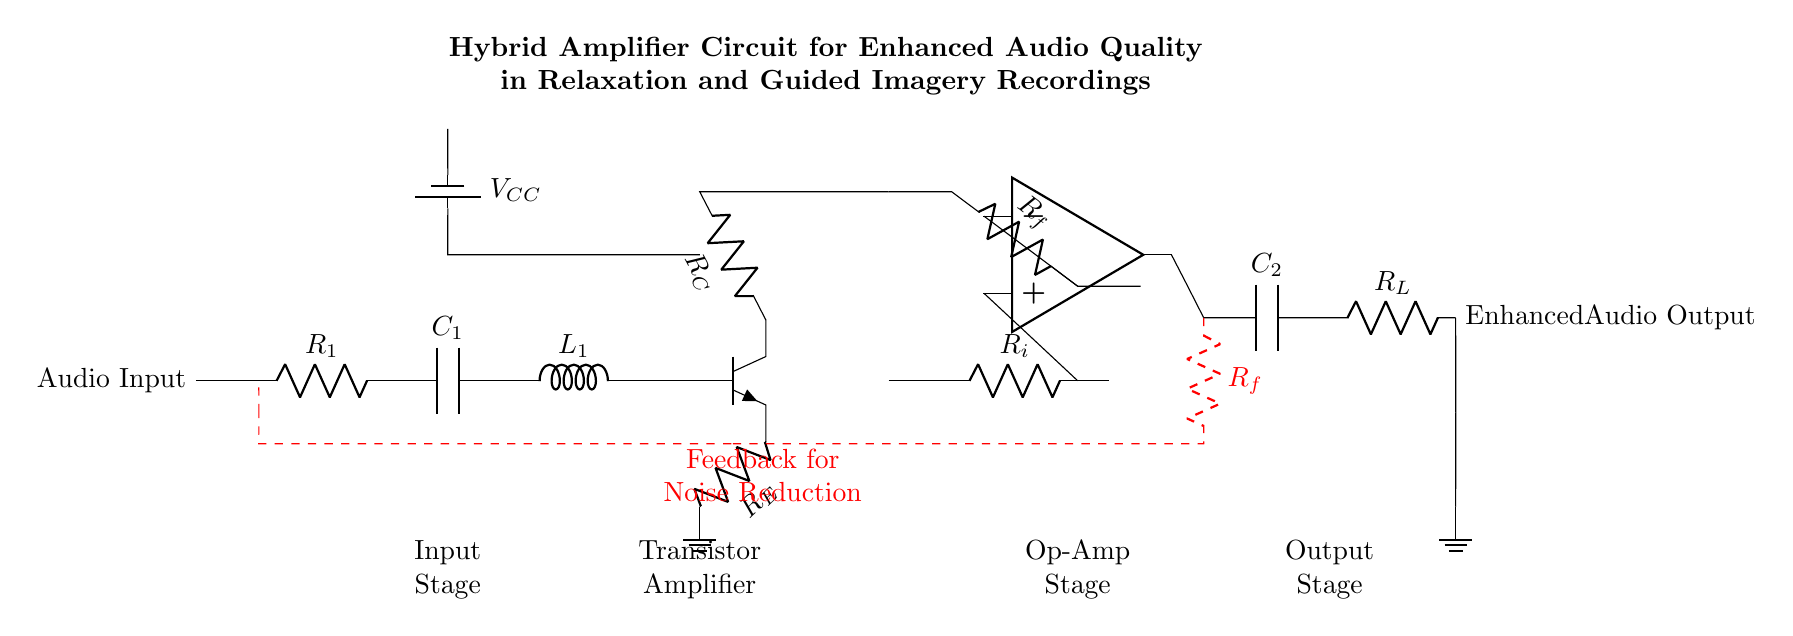What is the power supply voltage in this circuit? The voltage from the power supply is labeled as \( V_{CC} \) in the circuit diagram. It is represented next to the battery symbol, indicating that it provides the necessary voltage for the circuit operation.
Answer: VCC What type of transistor is used in this amplifier? The diagram indicates an NP transistor with the label npn next to the transistor symbol, identifying its type as an NPN transistor, commonly used in amplifier circuits for signal amplification.
Answer: NPN What component is used for filtering in the output stage? The component labeled as \( C_2 \) in the output stage serves as a capacitor, which is typically used for filtering high-frequency noise and smoothing out the output signal to enhance audio quality.
Answer: Capacitor What role does the resistor \( R_f \) serve in this circuit? The feedback resistor labeled \( R_f \) is used in the feedback loop indicated by the red dashed line, which helps stabilize the gain of the operational amplifier and reduces noise further enhancing audio quality.
Answer: Feedback resistor What type of configuration is the operational amplifier set in? The operational amplifier is set in a non-inverting configuration based on its positive input connection from \( R_i \) and negative input connection from \( R_f \), which allows for improved signal gain and fidelity in the output.
Answer: Non-inverting What is the purpose of the inductor \( L_1 \) in this circuit? The inductor \( L_1 \) is used to block high-frequency noise and allows low-frequency audio signals to pass through, which is crucial in enhancing the audio quality, especially for relaxation recordings.
Answer: Noise filtering What does the label at the bottom left of the circuit represent? The label "Input Stage" at the bottom left indicates that the components connected there are responsible for accepting the audio input signal, which is the first step in the amplification process.
Answer: Input stage 